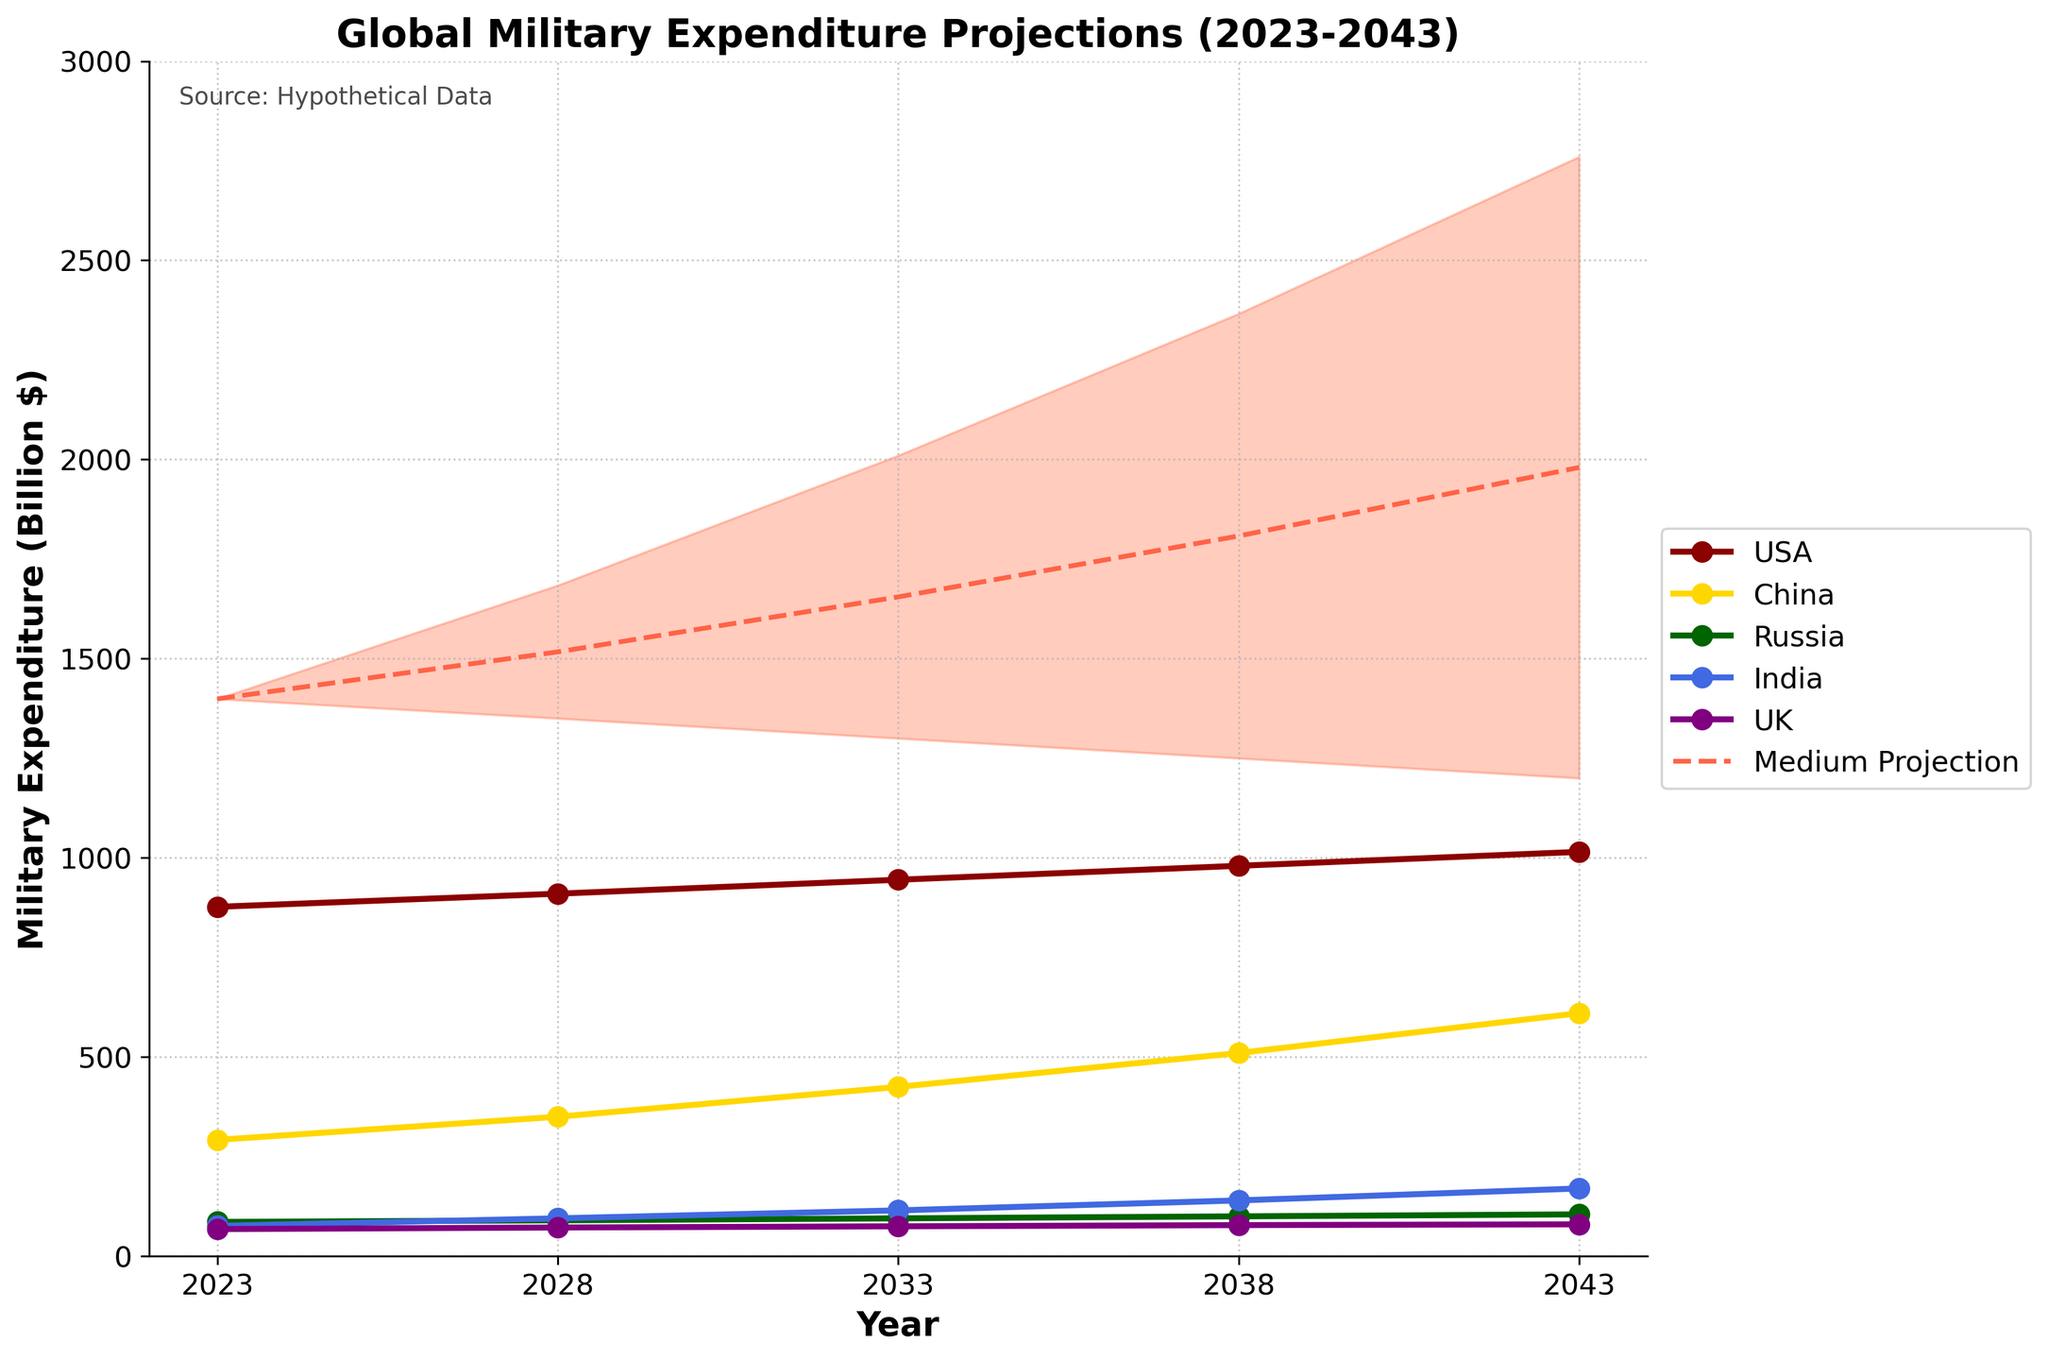what is the title of the figure? The title is typically located at the top of the figure. It is visually separated to make it clear and easily identifiable. The title of this figure is "Global Military Expenditure Projections (2023-2043)"
Answer: Global Military Expenditure Projections (2023-2043) Which country has the highest military expenditure in 2043? To determine this, we can look at the data points representing the year 2043 for each country. By comparing USA: 1015, China: 610, Russia: 105, India: 170, UK: 80, we see that the USA has the highest expenditure.
Answer: USA What is the range of the high expenditure projection for the year 2043? Look at the y-values associated with "High" in the year 2043. The high expenditure is represented by the value 2760 for that year.
Answer: 2760 What’s the difference in expenditure between the USA and Russia in 2043? For the year 2043, the USA has a military expenditure of 1015 billion dollars, while Russia has 105 billion dollars. The difference is calculated as 1015 - 105.
Answer: 910 How does the medium projection change from 2023 to 2043? Medium projections for the years 2023 and 2043 are given as 1399 and 1980, respectively. The change can be determined by calculating the difference 1980 - 1399.
Answer: 581 Which year shows the highest medium projection? Examine the medium projections across all years: 1399 (2023), 1517 (2028), 1655 (2033), 1808 (2038), 1980 (2043). The year with the highest medium projection is 2043.
Answer: 2043 Compare the military expenditures of India and the UK in 2038. Which is higher? For the year 2038, India has a military expenditure of 140 billion dollars and the UK has 78 billion dollars. India’s expenditure is higher.
Answer: India What is the trend in China's military expenditure from 2023 to 2043? Observing the values for China from 2023 to 2043 (292, 350, 425, 510, 610), we can see a steady upward trend, meaning China's military expenditure increases over time.
Answer: Increasing Examine the low projection trend from 2023 to 2043. What do you observe? The values for the low projections over the years are 1399 (2023), 1350 (2028), 1300 (2033), 1250 (2038), 1200 (2043). This shows a downward trend, indicating that the low projection decreases over time.
Answer: Decreasing 